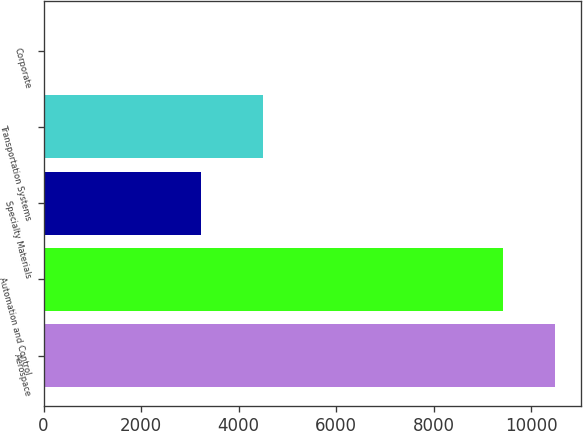<chart> <loc_0><loc_0><loc_500><loc_500><bar_chart><fcel>Aerospace<fcel>Automation and Control<fcel>Specialty Materials<fcel>Transportation Systems<fcel>Corporate<nl><fcel>10497<fcel>9416<fcel>3234<fcel>4505<fcel>1<nl></chart> 